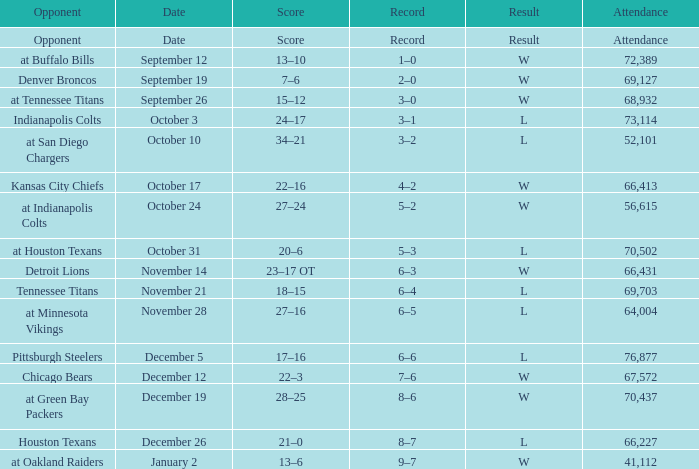What attendance has detroit lions as the opponent? 66431.0. 